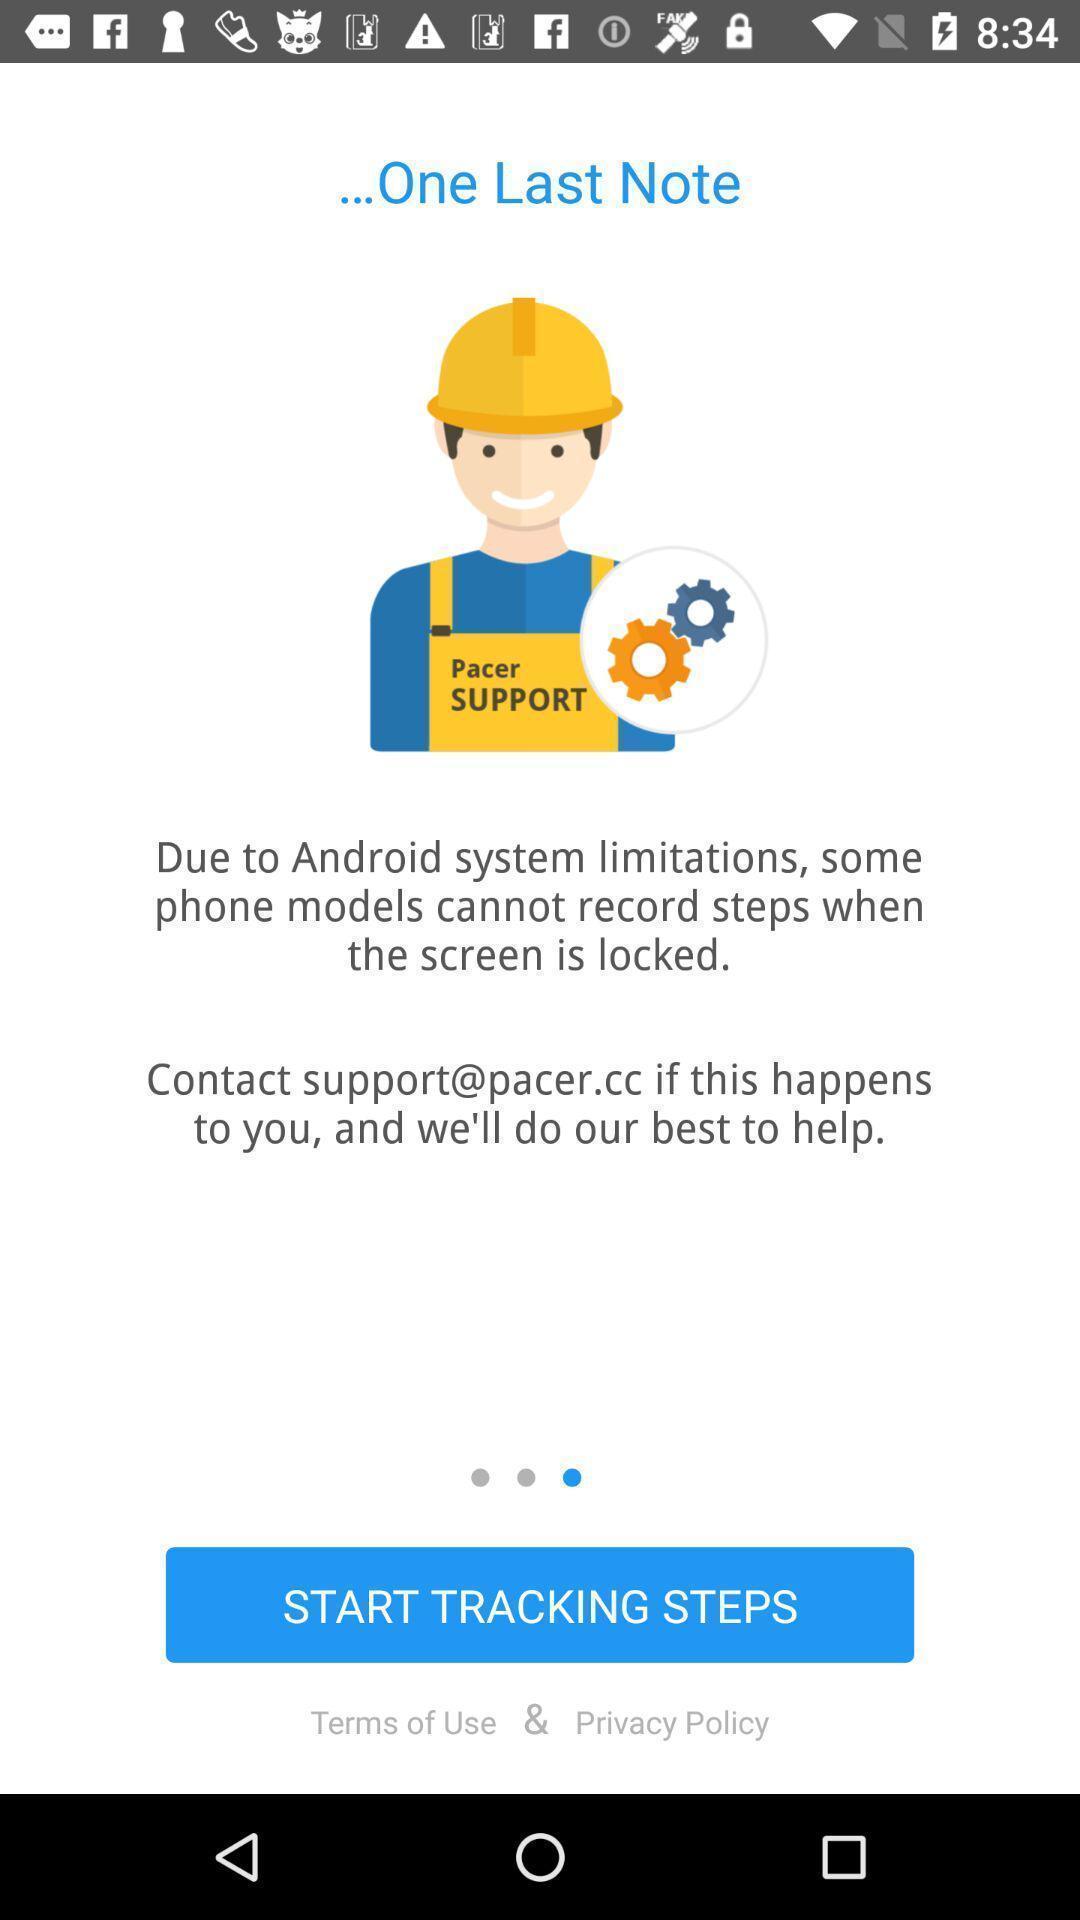Describe the key features of this screenshot. Welcome page of a fitness app. 